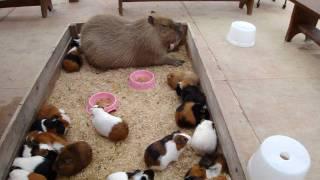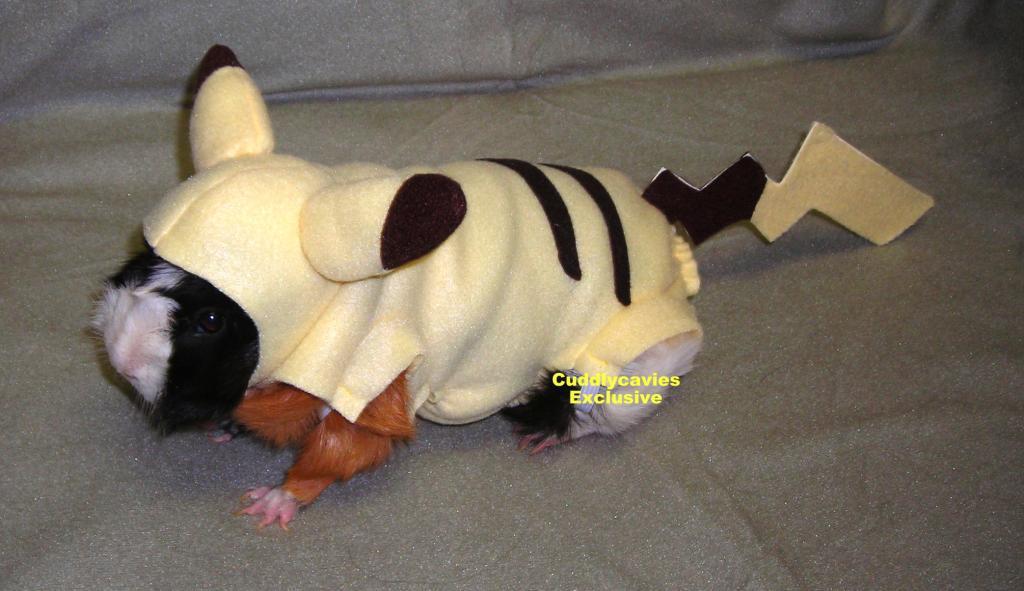The first image is the image on the left, the second image is the image on the right. For the images shown, is this caption "An image shows guinea pigs gathered around something """"organic"""" to eat." true? Answer yes or no. No. The first image is the image on the left, the second image is the image on the right. Examine the images to the left and right. Is the description "All of the guinea pigs are outside and some of them are eating greens." accurate? Answer yes or no. No. 